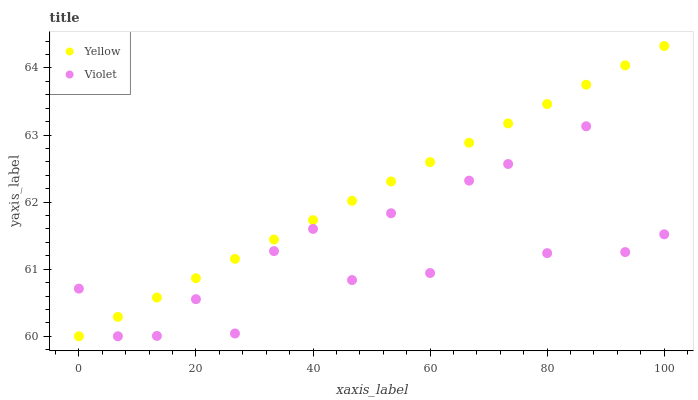Does Violet have the minimum area under the curve?
Answer yes or no. Yes. Does Yellow have the maximum area under the curve?
Answer yes or no. Yes. Does Violet have the maximum area under the curve?
Answer yes or no. No. Is Yellow the smoothest?
Answer yes or no. Yes. Is Violet the roughest?
Answer yes or no. Yes. Is Violet the smoothest?
Answer yes or no. No. Does Yellow have the lowest value?
Answer yes or no. Yes. Does Yellow have the highest value?
Answer yes or no. Yes. Does Violet have the highest value?
Answer yes or no. No. Does Violet intersect Yellow?
Answer yes or no. Yes. Is Violet less than Yellow?
Answer yes or no. No. Is Violet greater than Yellow?
Answer yes or no. No. 